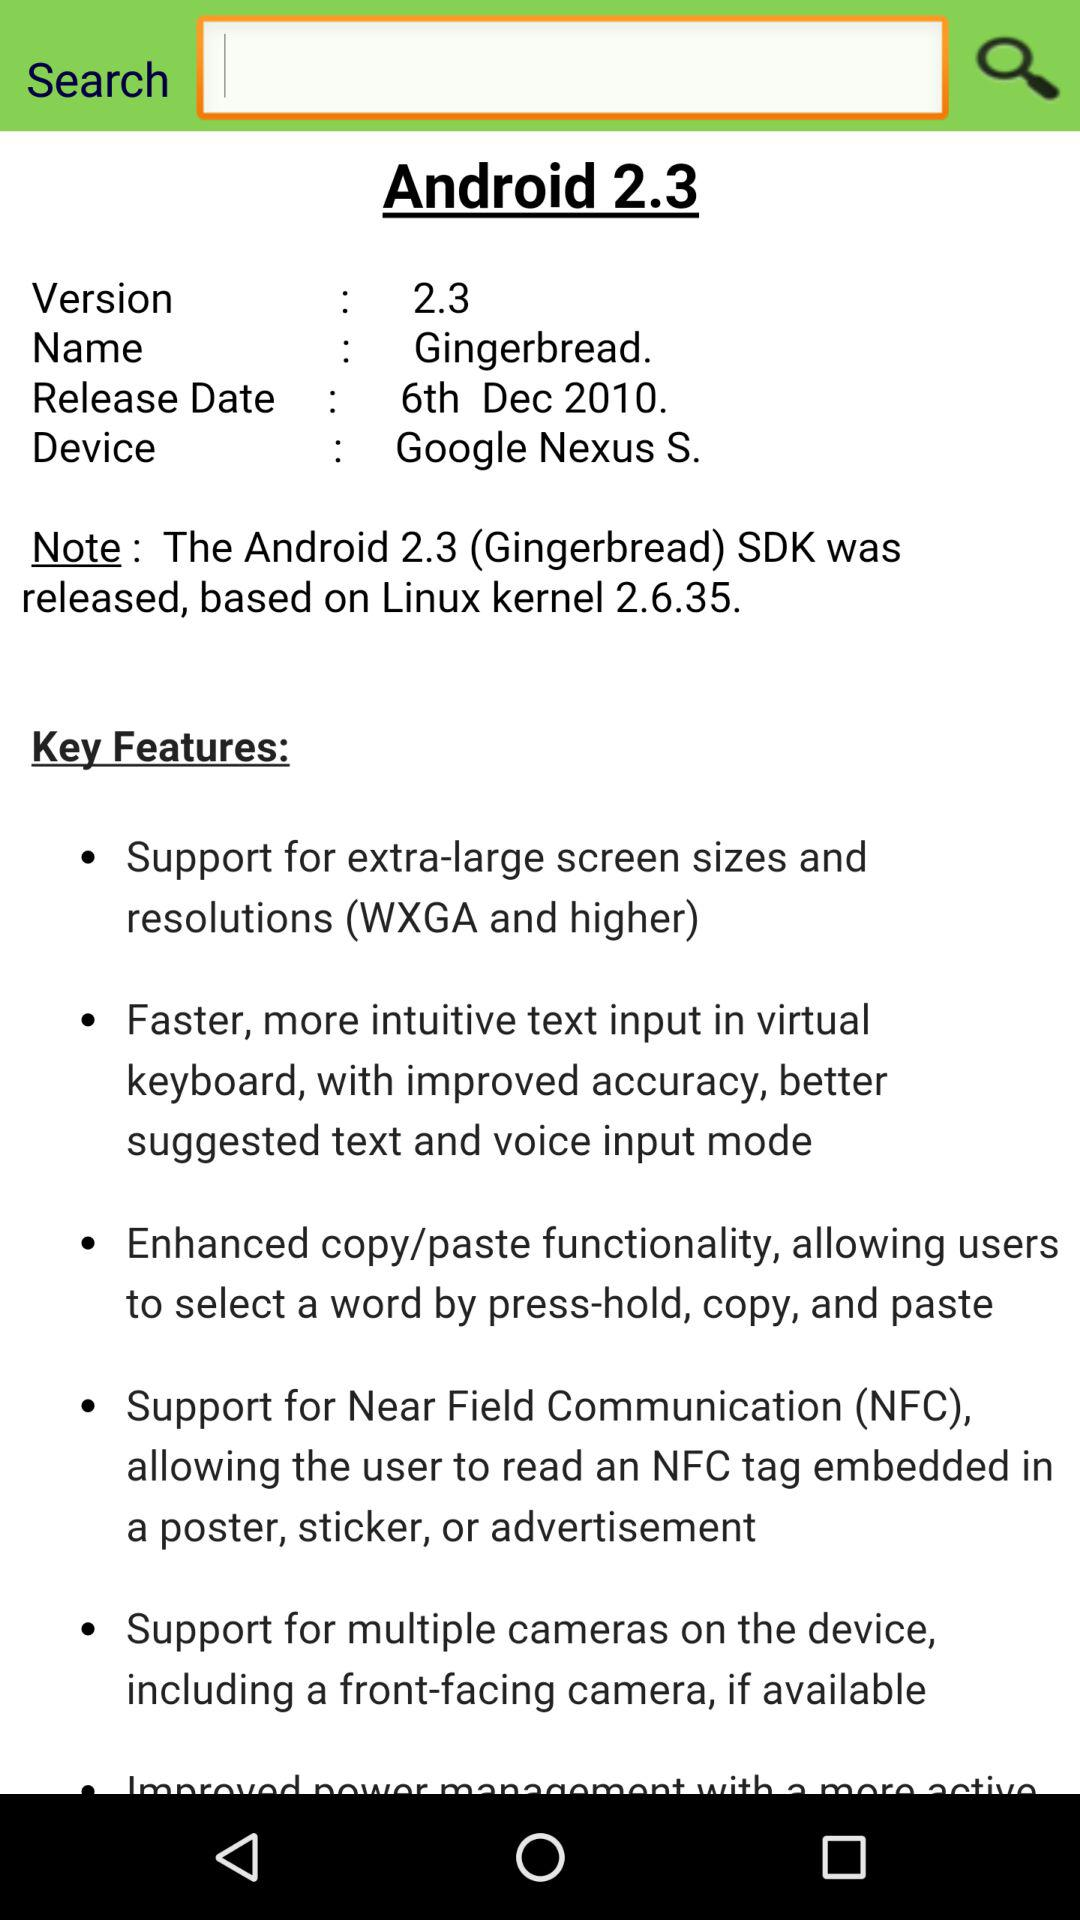Which Android version is used? The used Android version is 2.3. 